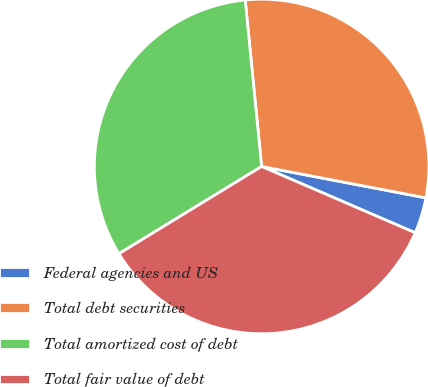Convert chart to OTSL. <chart><loc_0><loc_0><loc_500><loc_500><pie_chart><fcel>Federal agencies and US<fcel>Total debt securities<fcel>Total amortized cost of debt<fcel>Total fair value of debt<nl><fcel>3.48%<fcel>29.57%<fcel>32.17%<fcel>34.78%<nl></chart> 